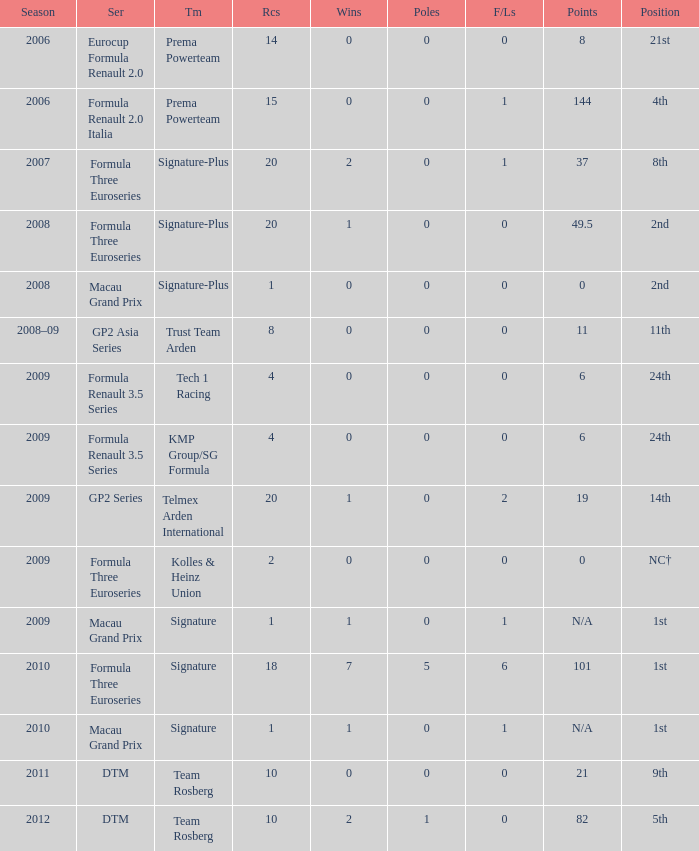Which series has 11 points? GP2 Asia Series. 